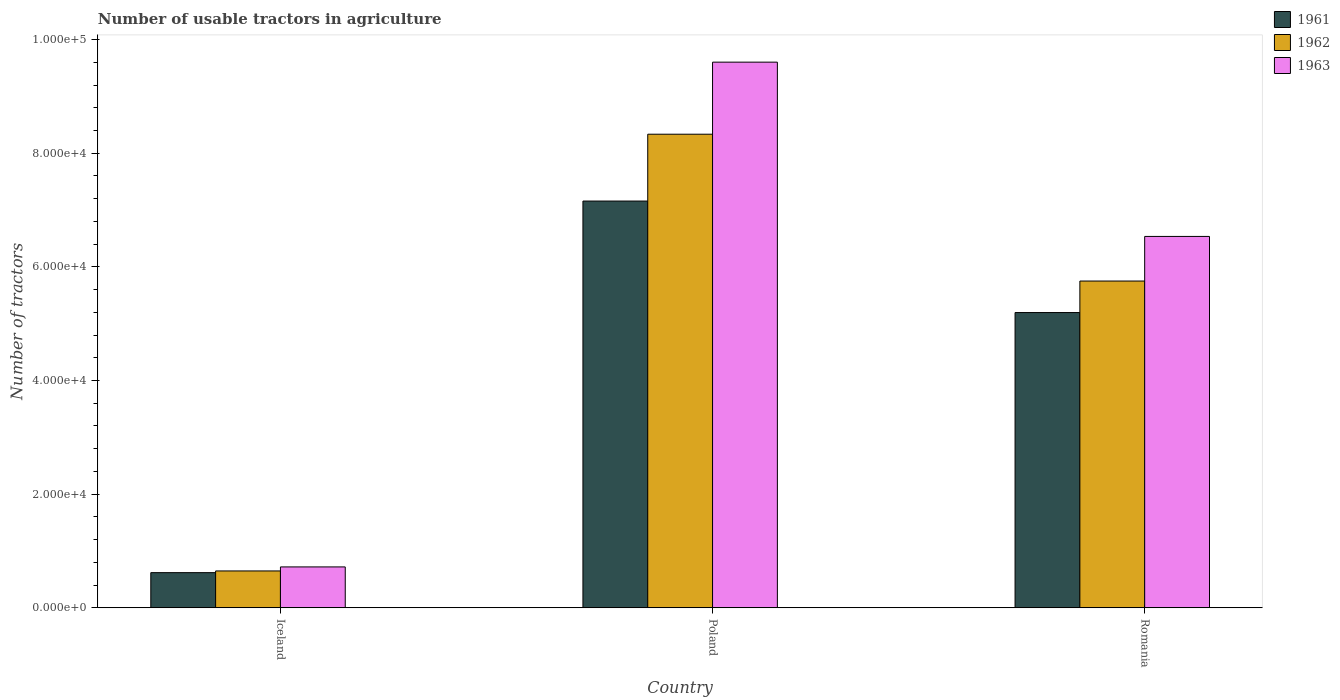How many different coloured bars are there?
Your answer should be very brief. 3. Are the number of bars per tick equal to the number of legend labels?
Your response must be concise. Yes. Are the number of bars on each tick of the X-axis equal?
Offer a very short reply. Yes. What is the label of the 3rd group of bars from the left?
Give a very brief answer. Romania. In how many cases, is the number of bars for a given country not equal to the number of legend labels?
Your response must be concise. 0. What is the number of usable tractors in agriculture in 1962 in Iceland?
Your answer should be compact. 6479. Across all countries, what is the maximum number of usable tractors in agriculture in 1961?
Provide a short and direct response. 7.16e+04. Across all countries, what is the minimum number of usable tractors in agriculture in 1962?
Provide a succinct answer. 6479. In which country was the number of usable tractors in agriculture in 1961 maximum?
Ensure brevity in your answer.  Poland. What is the total number of usable tractors in agriculture in 1961 in the graph?
Give a very brief answer. 1.30e+05. What is the difference between the number of usable tractors in agriculture in 1963 in Poland and that in Romania?
Provide a short and direct response. 3.07e+04. What is the difference between the number of usable tractors in agriculture in 1962 in Romania and the number of usable tractors in agriculture in 1963 in Poland?
Your answer should be compact. -3.85e+04. What is the average number of usable tractors in agriculture in 1962 per country?
Provide a short and direct response. 4.91e+04. What is the difference between the number of usable tractors in agriculture of/in 1963 and number of usable tractors in agriculture of/in 1961 in Poland?
Make the answer very short. 2.44e+04. In how many countries, is the number of usable tractors in agriculture in 1963 greater than 92000?
Provide a succinct answer. 1. What is the ratio of the number of usable tractors in agriculture in 1963 in Iceland to that in Poland?
Your answer should be compact. 0.07. Is the number of usable tractors in agriculture in 1963 in Poland less than that in Romania?
Make the answer very short. No. Is the difference between the number of usable tractors in agriculture in 1963 in Poland and Romania greater than the difference between the number of usable tractors in agriculture in 1961 in Poland and Romania?
Ensure brevity in your answer.  Yes. What is the difference between the highest and the second highest number of usable tractors in agriculture in 1962?
Provide a succinct answer. -2.58e+04. What is the difference between the highest and the lowest number of usable tractors in agriculture in 1961?
Ensure brevity in your answer.  6.54e+04. Is it the case that in every country, the sum of the number of usable tractors in agriculture in 1963 and number of usable tractors in agriculture in 1961 is greater than the number of usable tractors in agriculture in 1962?
Your response must be concise. Yes. How many bars are there?
Provide a succinct answer. 9. How many countries are there in the graph?
Your response must be concise. 3. Does the graph contain any zero values?
Your answer should be very brief. No. How many legend labels are there?
Ensure brevity in your answer.  3. What is the title of the graph?
Your response must be concise. Number of usable tractors in agriculture. Does "1980" appear as one of the legend labels in the graph?
Ensure brevity in your answer.  No. What is the label or title of the Y-axis?
Make the answer very short. Number of tractors. What is the Number of tractors of 1961 in Iceland?
Offer a very short reply. 6177. What is the Number of tractors in 1962 in Iceland?
Provide a succinct answer. 6479. What is the Number of tractors of 1963 in Iceland?
Your answer should be compact. 7187. What is the Number of tractors in 1961 in Poland?
Provide a succinct answer. 7.16e+04. What is the Number of tractors in 1962 in Poland?
Provide a succinct answer. 8.33e+04. What is the Number of tractors in 1963 in Poland?
Your answer should be very brief. 9.60e+04. What is the Number of tractors of 1961 in Romania?
Provide a succinct answer. 5.20e+04. What is the Number of tractors of 1962 in Romania?
Provide a succinct answer. 5.75e+04. What is the Number of tractors of 1963 in Romania?
Offer a very short reply. 6.54e+04. Across all countries, what is the maximum Number of tractors of 1961?
Your answer should be very brief. 7.16e+04. Across all countries, what is the maximum Number of tractors in 1962?
Offer a terse response. 8.33e+04. Across all countries, what is the maximum Number of tractors of 1963?
Ensure brevity in your answer.  9.60e+04. Across all countries, what is the minimum Number of tractors of 1961?
Keep it short and to the point. 6177. Across all countries, what is the minimum Number of tractors in 1962?
Provide a short and direct response. 6479. Across all countries, what is the minimum Number of tractors of 1963?
Offer a very short reply. 7187. What is the total Number of tractors in 1961 in the graph?
Offer a terse response. 1.30e+05. What is the total Number of tractors in 1962 in the graph?
Your answer should be very brief. 1.47e+05. What is the total Number of tractors of 1963 in the graph?
Make the answer very short. 1.69e+05. What is the difference between the Number of tractors in 1961 in Iceland and that in Poland?
Your answer should be very brief. -6.54e+04. What is the difference between the Number of tractors of 1962 in Iceland and that in Poland?
Offer a very short reply. -7.69e+04. What is the difference between the Number of tractors in 1963 in Iceland and that in Poland?
Your answer should be compact. -8.88e+04. What is the difference between the Number of tractors of 1961 in Iceland and that in Romania?
Keep it short and to the point. -4.58e+04. What is the difference between the Number of tractors of 1962 in Iceland and that in Romania?
Your answer should be compact. -5.10e+04. What is the difference between the Number of tractors in 1963 in Iceland and that in Romania?
Give a very brief answer. -5.82e+04. What is the difference between the Number of tractors in 1961 in Poland and that in Romania?
Offer a very short reply. 1.96e+04. What is the difference between the Number of tractors in 1962 in Poland and that in Romania?
Your response must be concise. 2.58e+04. What is the difference between the Number of tractors of 1963 in Poland and that in Romania?
Ensure brevity in your answer.  3.07e+04. What is the difference between the Number of tractors of 1961 in Iceland and the Number of tractors of 1962 in Poland?
Make the answer very short. -7.72e+04. What is the difference between the Number of tractors of 1961 in Iceland and the Number of tractors of 1963 in Poland?
Keep it short and to the point. -8.98e+04. What is the difference between the Number of tractors of 1962 in Iceland and the Number of tractors of 1963 in Poland?
Provide a short and direct response. -8.95e+04. What is the difference between the Number of tractors of 1961 in Iceland and the Number of tractors of 1962 in Romania?
Your response must be concise. -5.13e+04. What is the difference between the Number of tractors in 1961 in Iceland and the Number of tractors in 1963 in Romania?
Your answer should be compact. -5.92e+04. What is the difference between the Number of tractors in 1962 in Iceland and the Number of tractors in 1963 in Romania?
Give a very brief answer. -5.89e+04. What is the difference between the Number of tractors of 1961 in Poland and the Number of tractors of 1962 in Romania?
Your answer should be very brief. 1.41e+04. What is the difference between the Number of tractors in 1961 in Poland and the Number of tractors in 1963 in Romania?
Make the answer very short. 6226. What is the difference between the Number of tractors of 1962 in Poland and the Number of tractors of 1963 in Romania?
Provide a succinct answer. 1.80e+04. What is the average Number of tractors in 1961 per country?
Your response must be concise. 4.32e+04. What is the average Number of tractors of 1962 per country?
Your answer should be compact. 4.91e+04. What is the average Number of tractors in 1963 per country?
Ensure brevity in your answer.  5.62e+04. What is the difference between the Number of tractors in 1961 and Number of tractors in 1962 in Iceland?
Give a very brief answer. -302. What is the difference between the Number of tractors of 1961 and Number of tractors of 1963 in Iceland?
Ensure brevity in your answer.  -1010. What is the difference between the Number of tractors in 1962 and Number of tractors in 1963 in Iceland?
Ensure brevity in your answer.  -708. What is the difference between the Number of tractors of 1961 and Number of tractors of 1962 in Poland?
Offer a terse response. -1.18e+04. What is the difference between the Number of tractors in 1961 and Number of tractors in 1963 in Poland?
Ensure brevity in your answer.  -2.44e+04. What is the difference between the Number of tractors of 1962 and Number of tractors of 1963 in Poland?
Make the answer very short. -1.27e+04. What is the difference between the Number of tractors in 1961 and Number of tractors in 1962 in Romania?
Offer a very short reply. -5548. What is the difference between the Number of tractors of 1961 and Number of tractors of 1963 in Romania?
Provide a succinct answer. -1.34e+04. What is the difference between the Number of tractors in 1962 and Number of tractors in 1963 in Romania?
Offer a very short reply. -7851. What is the ratio of the Number of tractors of 1961 in Iceland to that in Poland?
Your response must be concise. 0.09. What is the ratio of the Number of tractors of 1962 in Iceland to that in Poland?
Make the answer very short. 0.08. What is the ratio of the Number of tractors in 1963 in Iceland to that in Poland?
Ensure brevity in your answer.  0.07. What is the ratio of the Number of tractors in 1961 in Iceland to that in Romania?
Provide a short and direct response. 0.12. What is the ratio of the Number of tractors in 1962 in Iceland to that in Romania?
Offer a terse response. 0.11. What is the ratio of the Number of tractors in 1963 in Iceland to that in Romania?
Offer a terse response. 0.11. What is the ratio of the Number of tractors in 1961 in Poland to that in Romania?
Offer a very short reply. 1.38. What is the ratio of the Number of tractors in 1962 in Poland to that in Romania?
Offer a terse response. 1.45. What is the ratio of the Number of tractors in 1963 in Poland to that in Romania?
Ensure brevity in your answer.  1.47. What is the difference between the highest and the second highest Number of tractors in 1961?
Your response must be concise. 1.96e+04. What is the difference between the highest and the second highest Number of tractors of 1962?
Offer a terse response. 2.58e+04. What is the difference between the highest and the second highest Number of tractors in 1963?
Your answer should be compact. 3.07e+04. What is the difference between the highest and the lowest Number of tractors in 1961?
Keep it short and to the point. 6.54e+04. What is the difference between the highest and the lowest Number of tractors in 1962?
Provide a short and direct response. 7.69e+04. What is the difference between the highest and the lowest Number of tractors of 1963?
Offer a very short reply. 8.88e+04. 